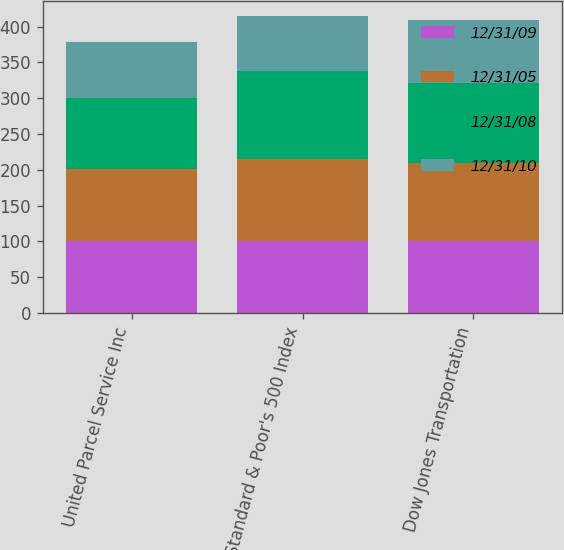Convert chart to OTSL. <chart><loc_0><loc_0><loc_500><loc_500><stacked_bar_chart><ecel><fcel>United Parcel Service Inc<fcel>Standard & Poor's 500 Index<fcel>Dow Jones Transportation<nl><fcel>12/31/09<fcel>100<fcel>100<fcel>100<nl><fcel>12/31/05<fcel>101.76<fcel>115.79<fcel>109.82<nl><fcel>12/31/08<fcel>98.2<fcel>122.16<fcel>111.38<nl><fcel>12/31/10<fcel>78.76<fcel>76.96<fcel>87.52<nl></chart> 